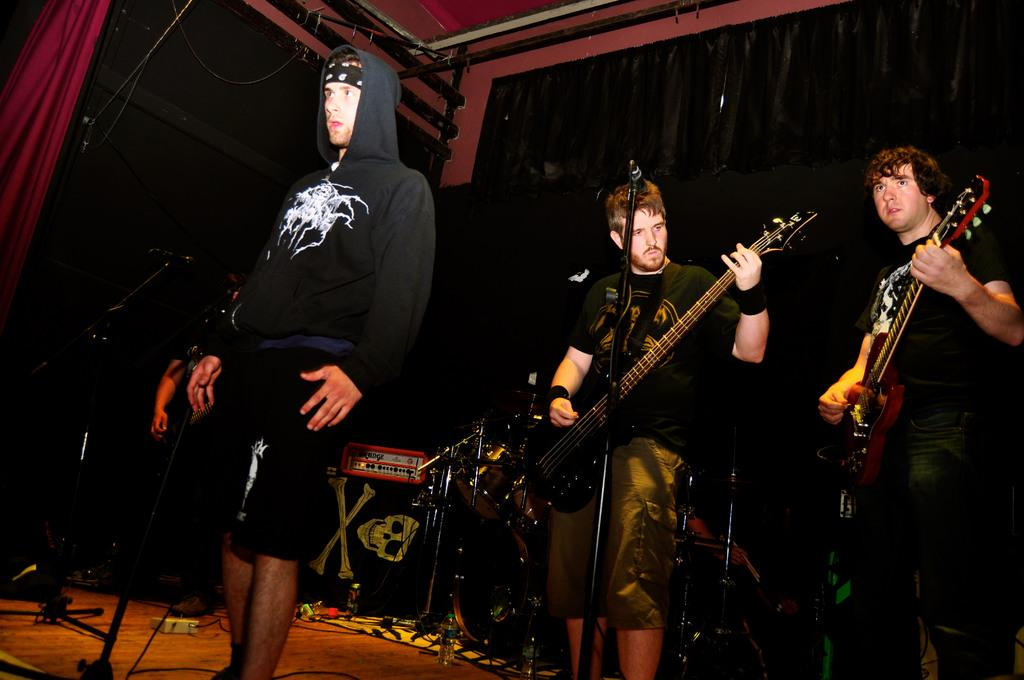How many people are playing a guitar in the image? There are two men playing a guitar in the image. What is the third person in the image doing? There is a man standing in the image. What object is used for amplifying sound in the image? There is a microphone (mic) in the image. What can be seen in the background of the image? There are musical instruments in the background of the image. What type of drink is being served in the image? There is no drink present in the image; it features two men playing a guitar, a standing man, a microphone, and musical instruments in the background. What type of tree can be seen in the image? There is no tree present in the image. 